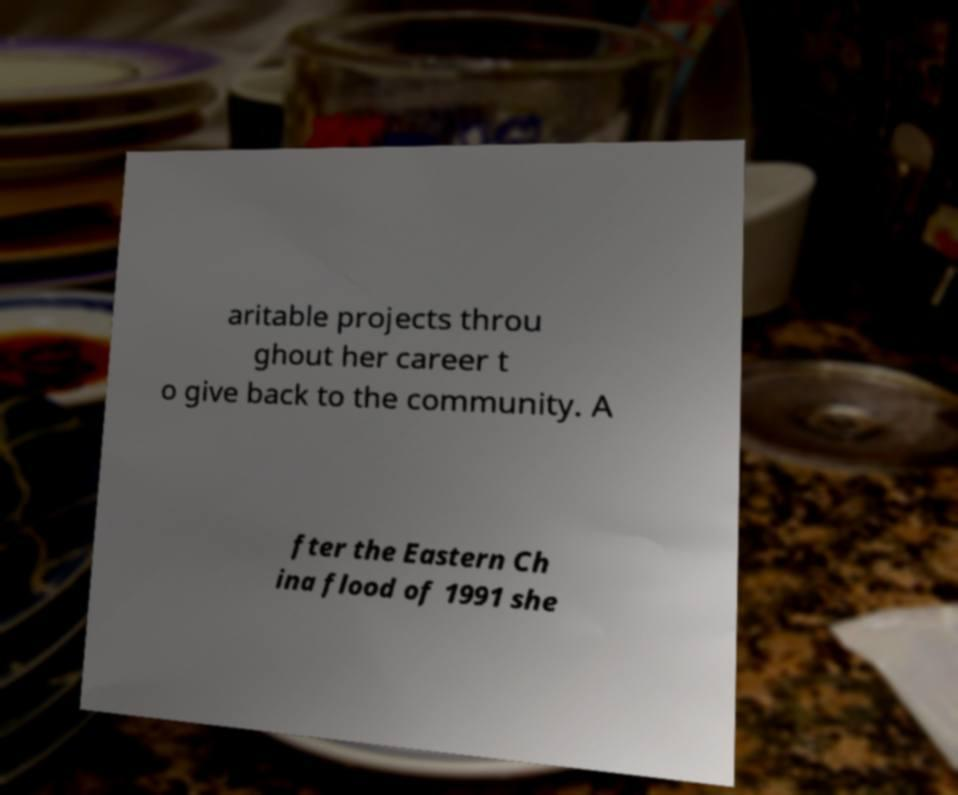Can you read and provide the text displayed in the image?This photo seems to have some interesting text. Can you extract and type it out for me? aritable projects throu ghout her career t o give back to the community. A fter the Eastern Ch ina flood of 1991 she 